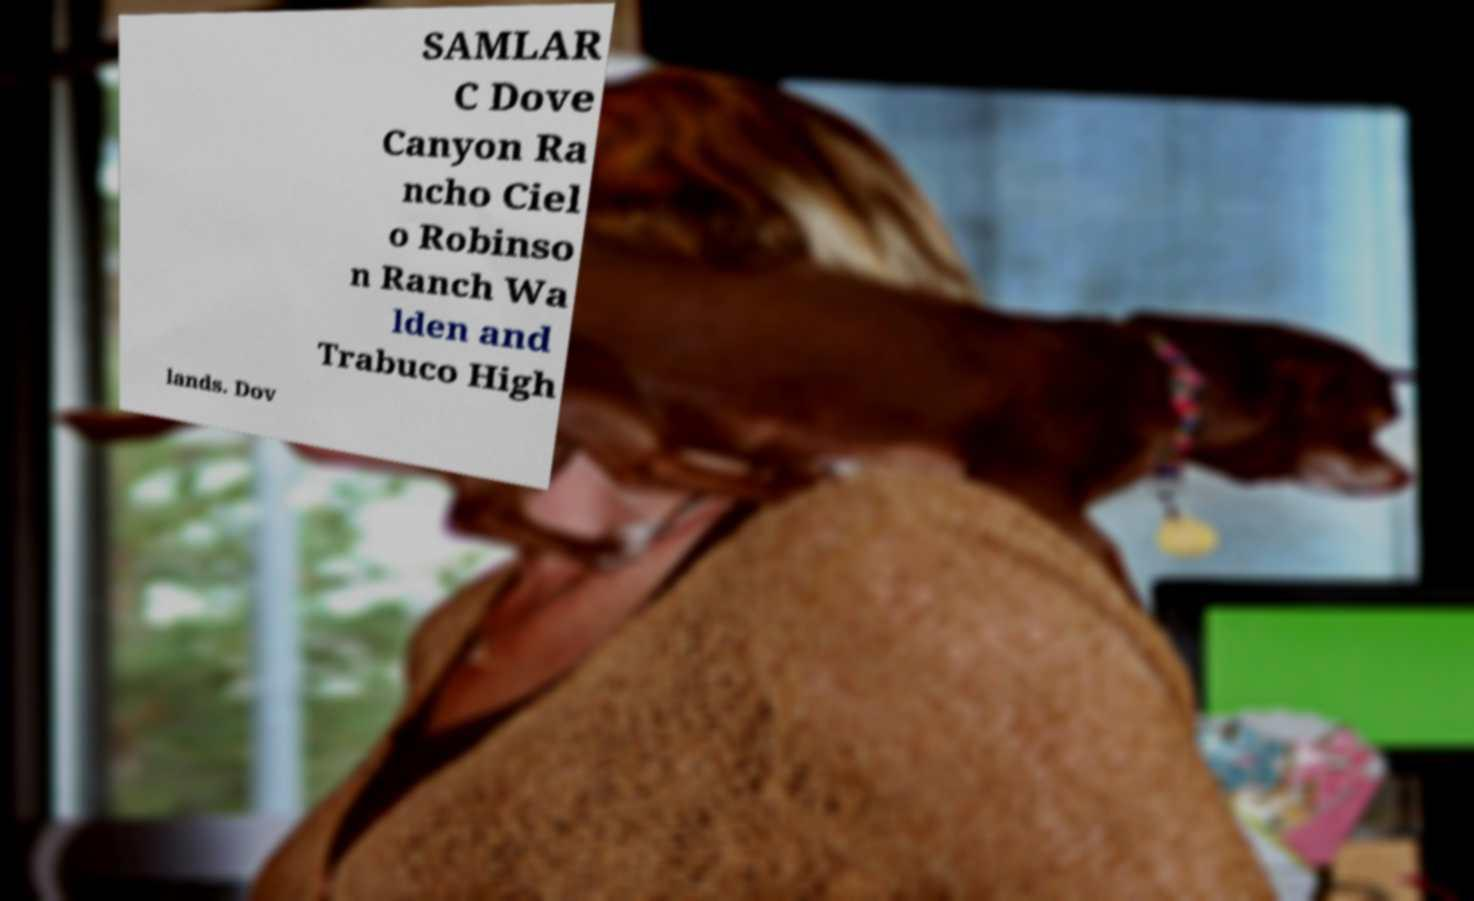For documentation purposes, I need the text within this image transcribed. Could you provide that? SAMLAR C Dove Canyon Ra ncho Ciel o Robinso n Ranch Wa lden and Trabuco High lands. Dov 